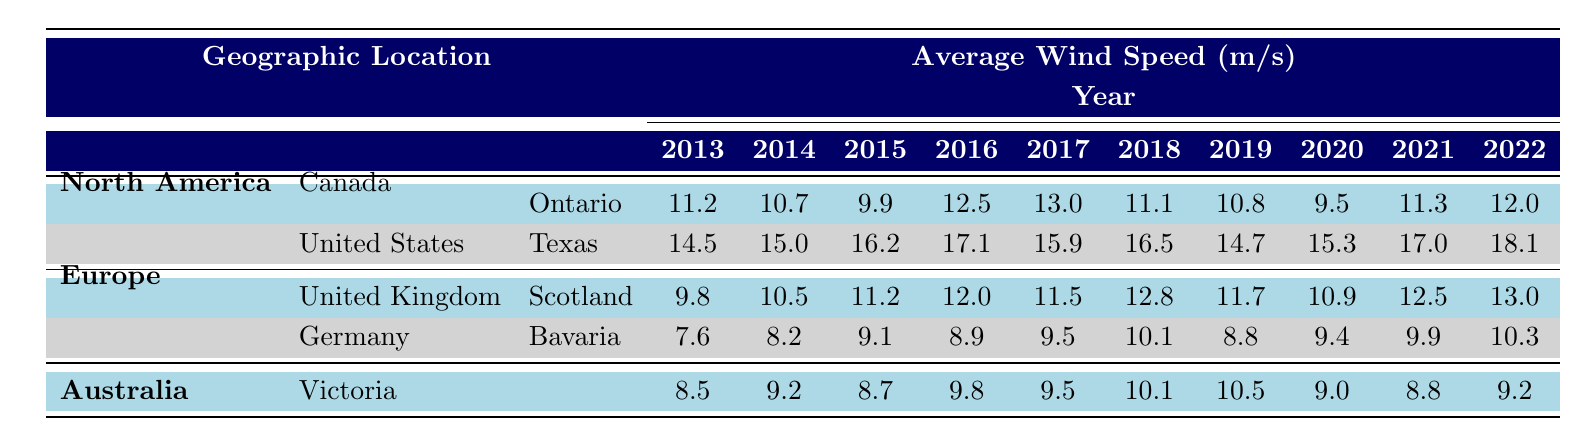What was the average wind speed in Ontario in 2017? According to the table, the average wind speed listed for Ontario in 2017 is 13.0 m/s.
Answer: 13.0 m/s What was the wind speed trend in Texas from 2013 to 2022? By looking at the data for Texas from 2013 to 2022: 14.5, 15.0, 16.2, 17.1, 15.9, 16.5, 14.7, 15.3, 17.0, and 18.1, it shows a general increasing trend over the years with fluctuations in 2017 and 2019.
Answer: General increasing trend Was the average wind speed in Scotland higher than in Bavaria in 2020? The average wind speed in Scotland in 2020 is 10.9 m/s, while in Bavaria it is 9.4 m/s. So, yes, Scotland's average wind speed was higher.
Answer: Yes What is the difference in average wind speed between Ontario and Texas in 2021? The average wind speed in Ontario for 2021 is 11.3 m/s, and in Texas, it is 17.0 m/s. The difference is computed as 17.0 - 11.3 = 5.7 m/s.
Answer: 5.7 m/s Which region had the highest average wind speed in 2019? For 2019, Ontario has 10.8 m/s, Texas has 14.7 m/s, Scotland has 11.7 m/s, Bavaria has 8.8 m/s, and Victoria has 10.5 m/s. The highest average wind speed is from Texas at 14.7 m/s.
Answer: Texas If we consider the average wind speed of Victoria from 2013 to 2022, what was the trend? The average wind speed for Victoria is: 8.5, 9.2, 8.7, 9.8, 9.5, 10.1, 10.5, 9.0, 8.8, and 9.2. After an initial increase, it fluctuates, showing no steady trend.
Answer: No steady trend Was the average wind speed in Bavaria lower than 10 m/s in 2018? The average wind speed in Bavaria for 2018 is 10.1 m/s, which is higher than 10 m/s. Therefore, the statement is false.
Answer: No What was the average wind speed in all areas combined for the year 2022? Summing the average values for 2022 from all listed locations: Ontario (12.0) + Texas (18.1) + Scotland (13.0) + Bavaria (10.3) + Victoria (9.2) gives a total of 62.6 m/s. Dividing by the number of locations (5), the average is 62.6 / 5 = 12.52 m/s.
Answer: 12.52 m/s 